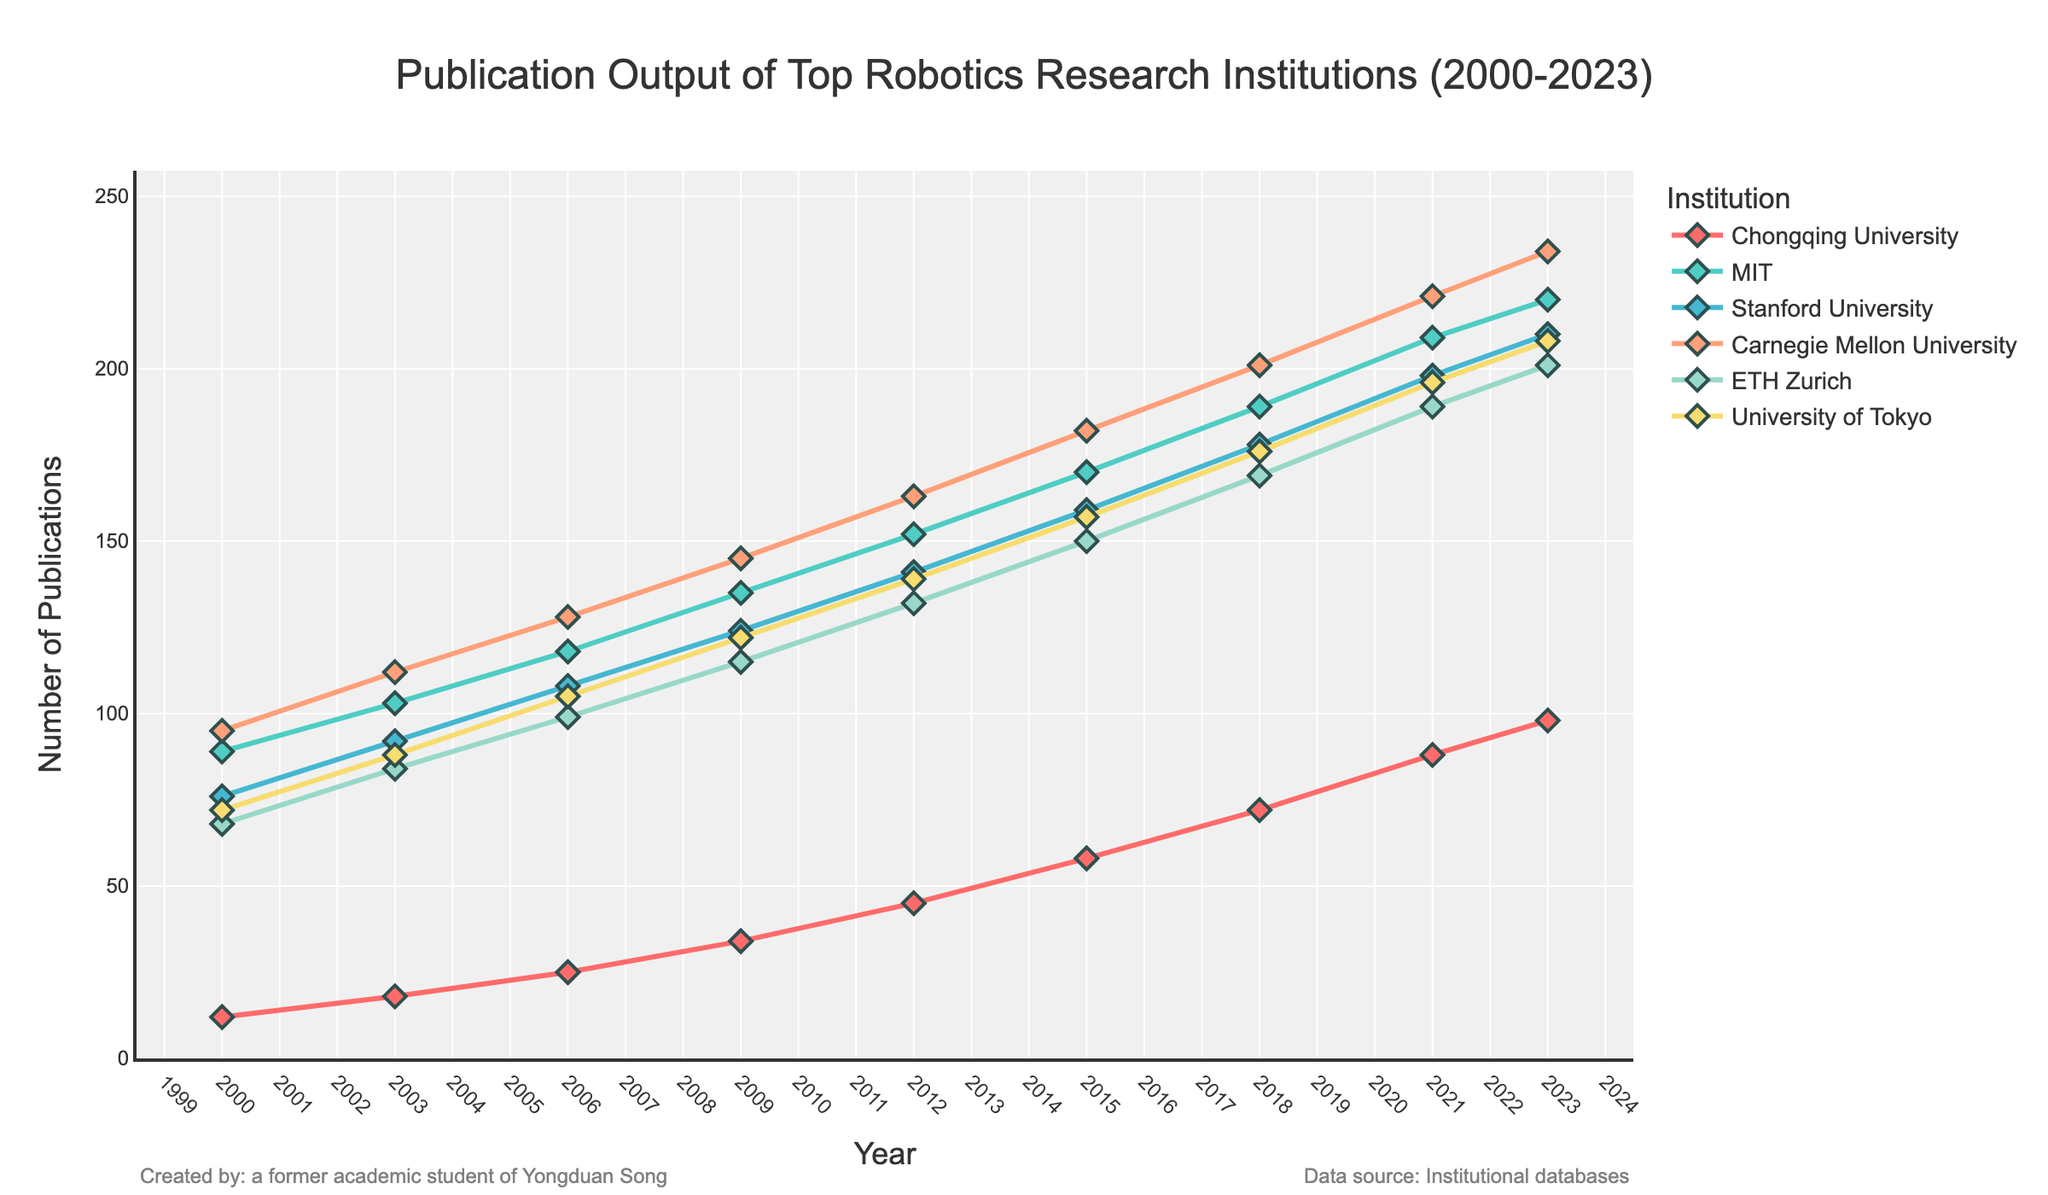What is the publication output of MIT in 2023 compared to 2000? To find the difference in publication output for MIT between 2023 and 2000, find the values for each year and subtract the 2000 value from the 2023 value. In 2023, MIT has 220 publications and in 2000, it had 89 publications. The difference is 220 - 89 = 131.
Answer: 131 Which institution had the highest number of publications in 2023? Look at the data points for each institution in the year 2023. The highest value among them is for Carnegie Mellon University with 234 publications.
Answer: Carnegie Mellon University How has the publication output for Chongqing University changed from 2000 to 2023? Calculate the difference in publication output for Chongqing University between 2023 and 2000. Chongqing University had 12 publications in 2000 and 98 in 2023. The difference is 98 - 12 = 86.
Answer: Increase by 86 Between 2009 and 2012, which institution had the largest increase in publication output? Calculate the increase in publication output for each institution from 2009 to 2012 by subtracting the 2009 values from the 2012 values. Chongqing University had a change of 45 - 34 = 11, MIT had 152 - 135 = 17, Stanford had 141 - 124 = 17, Carnegie Mellon had 163 - 145 = 18, ETH Zurich had 132 - 115 = 17, and University of Tokyo had 139 - 122 = 17. Carnegie Mellon had the largest increase of 18 publications.
Answer: Carnegie Mellon University What is the average publication output for ETH Zurich from 2000 to 2023? To find the average publication output, sum the values for ETH Zurich for all the years and divide by the number of years. The values are 68, 84, 99, 115, 132, 150, 169, 189, and 201. The sum is 1007. There are 9 years, so the average is 1007 / 9 ≈ 111.89.
Answer: Approximately 111.89 Which institution shows a consistent increase in publication output from 2000 to 2023 without any drops? By observing the lines, Chongqing University shows a consistent increase with no drops in its publication output across the years from 2000 to 2023.
Answer: Chongqing University What is the total publication output of Stanford University over the entire period? Sum the values for Stanford University for all the years: 76, 92, 108, 124, 141, 159, 178, 198, and 210. The total is 1286.
Answer: 1286 